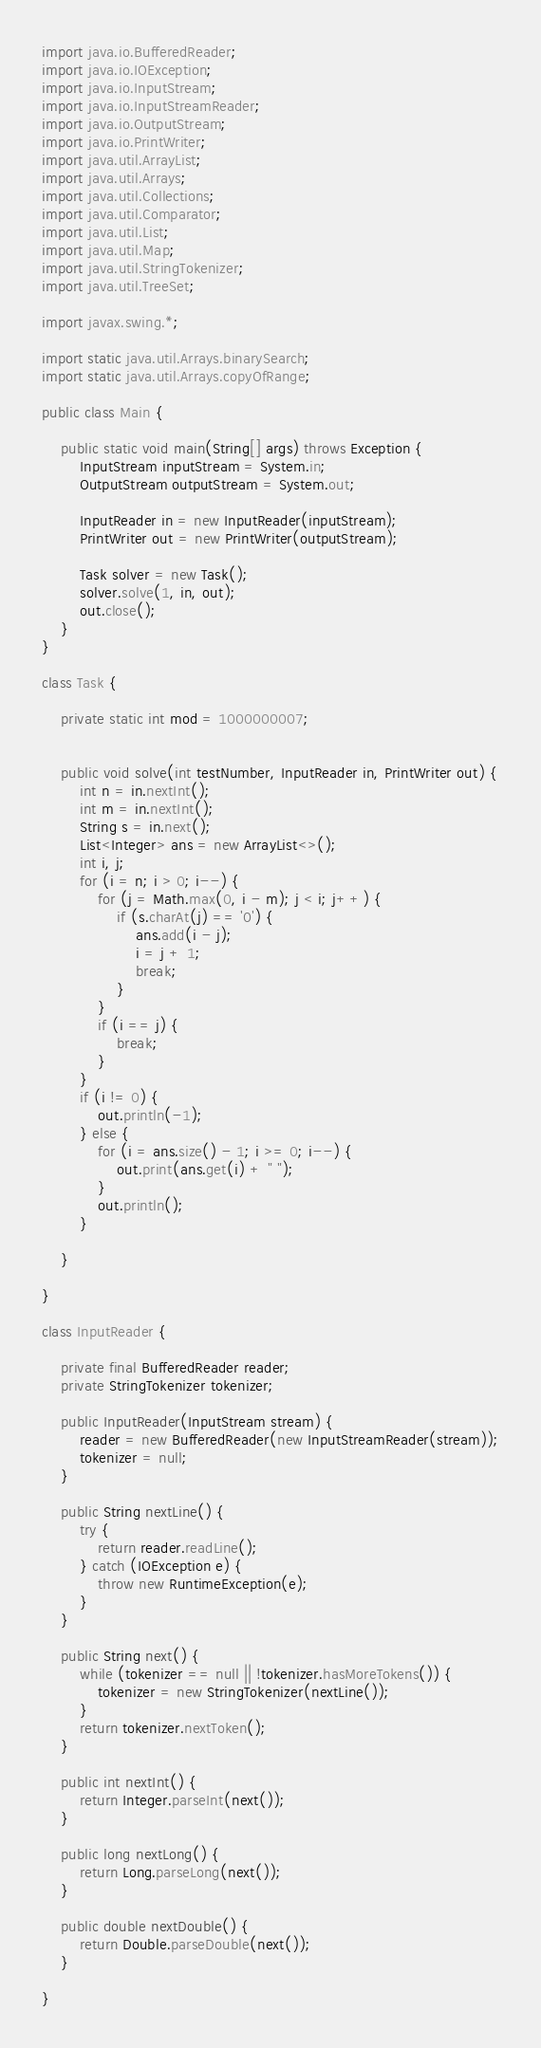Convert code to text. <code><loc_0><loc_0><loc_500><loc_500><_Java_>import java.io.BufferedReader;
import java.io.IOException;
import java.io.InputStream;
import java.io.InputStreamReader;
import java.io.OutputStream;
import java.io.PrintWriter;
import java.util.ArrayList;
import java.util.Arrays;
import java.util.Collections;
import java.util.Comparator;
import java.util.List;
import java.util.Map;
import java.util.StringTokenizer;
import java.util.TreeSet;

import javax.swing.*;

import static java.util.Arrays.binarySearch;
import static java.util.Arrays.copyOfRange;

public class Main {

    public static void main(String[] args) throws Exception {
        InputStream inputStream = System.in;
        OutputStream outputStream = System.out;

        InputReader in = new InputReader(inputStream);
        PrintWriter out = new PrintWriter(outputStream);

        Task solver = new Task();
        solver.solve(1, in, out);
        out.close();
    }
}

class Task {

    private static int mod = 1000000007;


    public void solve(int testNumber, InputReader in, PrintWriter out) {
        int n = in.nextInt();
        int m = in.nextInt();
        String s = in.next();
        List<Integer> ans = new ArrayList<>();
        int i, j;
        for (i = n; i > 0; i--) {
            for (j = Math.max(0, i - m); j < i; j++) {
                if (s.charAt(j) == '0') {
                    ans.add(i - j);
                    i = j + 1;
                    break;
                }
            }
            if (i == j) {
                break;
            }
        }
        if (i != 0) {
            out.println(-1);
        } else {
            for (i = ans.size() - 1; i >= 0; i--) {
                out.print(ans.get(i) + " ");
            }
            out.println();
        }

    }

}

class InputReader {

    private final BufferedReader reader;
    private StringTokenizer tokenizer;

    public InputReader(InputStream stream) {
        reader = new BufferedReader(new InputStreamReader(stream));
        tokenizer = null;
    }

    public String nextLine() {
        try {
            return reader.readLine();
        } catch (IOException e) {
            throw new RuntimeException(e);
        }
    }

    public String next() {
        while (tokenizer == null || !tokenizer.hasMoreTokens()) {
            tokenizer = new StringTokenizer(nextLine());
        }
        return tokenizer.nextToken();
    }

    public int nextInt() {
        return Integer.parseInt(next());
    }

    public long nextLong() {
        return Long.parseLong(next());
    }

    public double nextDouble() {
        return Double.parseDouble(next());
    }

}
</code> 